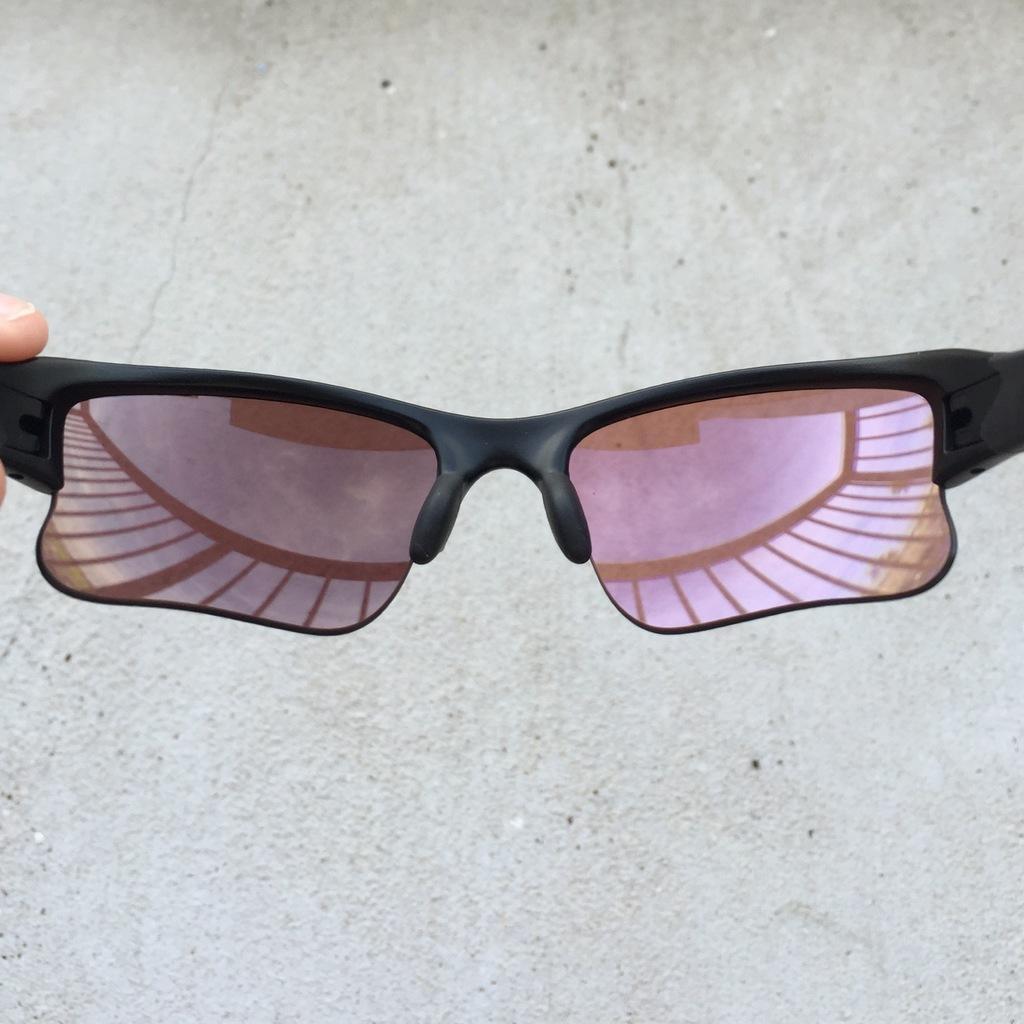Can you describe this image briefly? In this picture I can see the person's finger who is holding a sunglasses. In the back I can see the floor. In the glass reflection I can see the sky and clouds. 